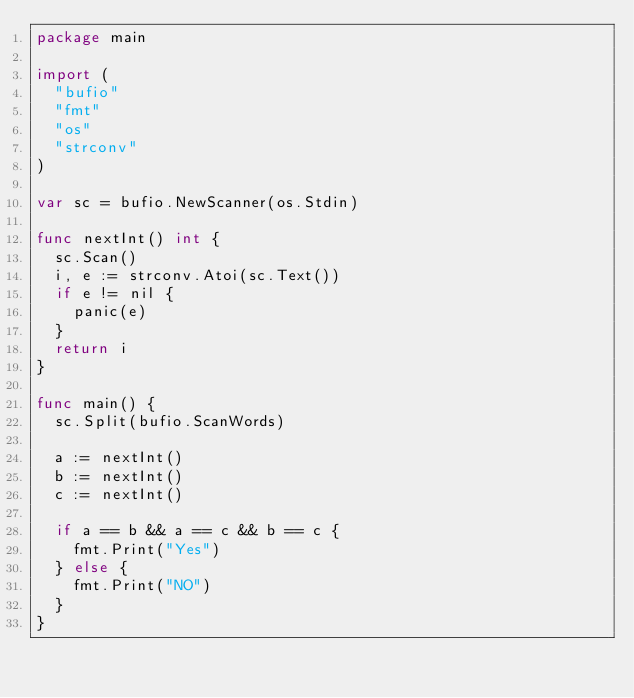Convert code to text. <code><loc_0><loc_0><loc_500><loc_500><_Go_>package main

import (
	"bufio"
	"fmt"
	"os"
	"strconv"
)

var sc = bufio.NewScanner(os.Stdin)

func nextInt() int {
	sc.Scan()
	i, e := strconv.Atoi(sc.Text())
	if e != nil {
		panic(e)
	}
	return i
}

func main() {
	sc.Split(bufio.ScanWords)

	a := nextInt()
	b := nextInt()
	c := nextInt()

	if a == b && a == c && b == c {
		fmt.Print("Yes")
	} else {
		fmt.Print("NO")
	}
}
</code> 